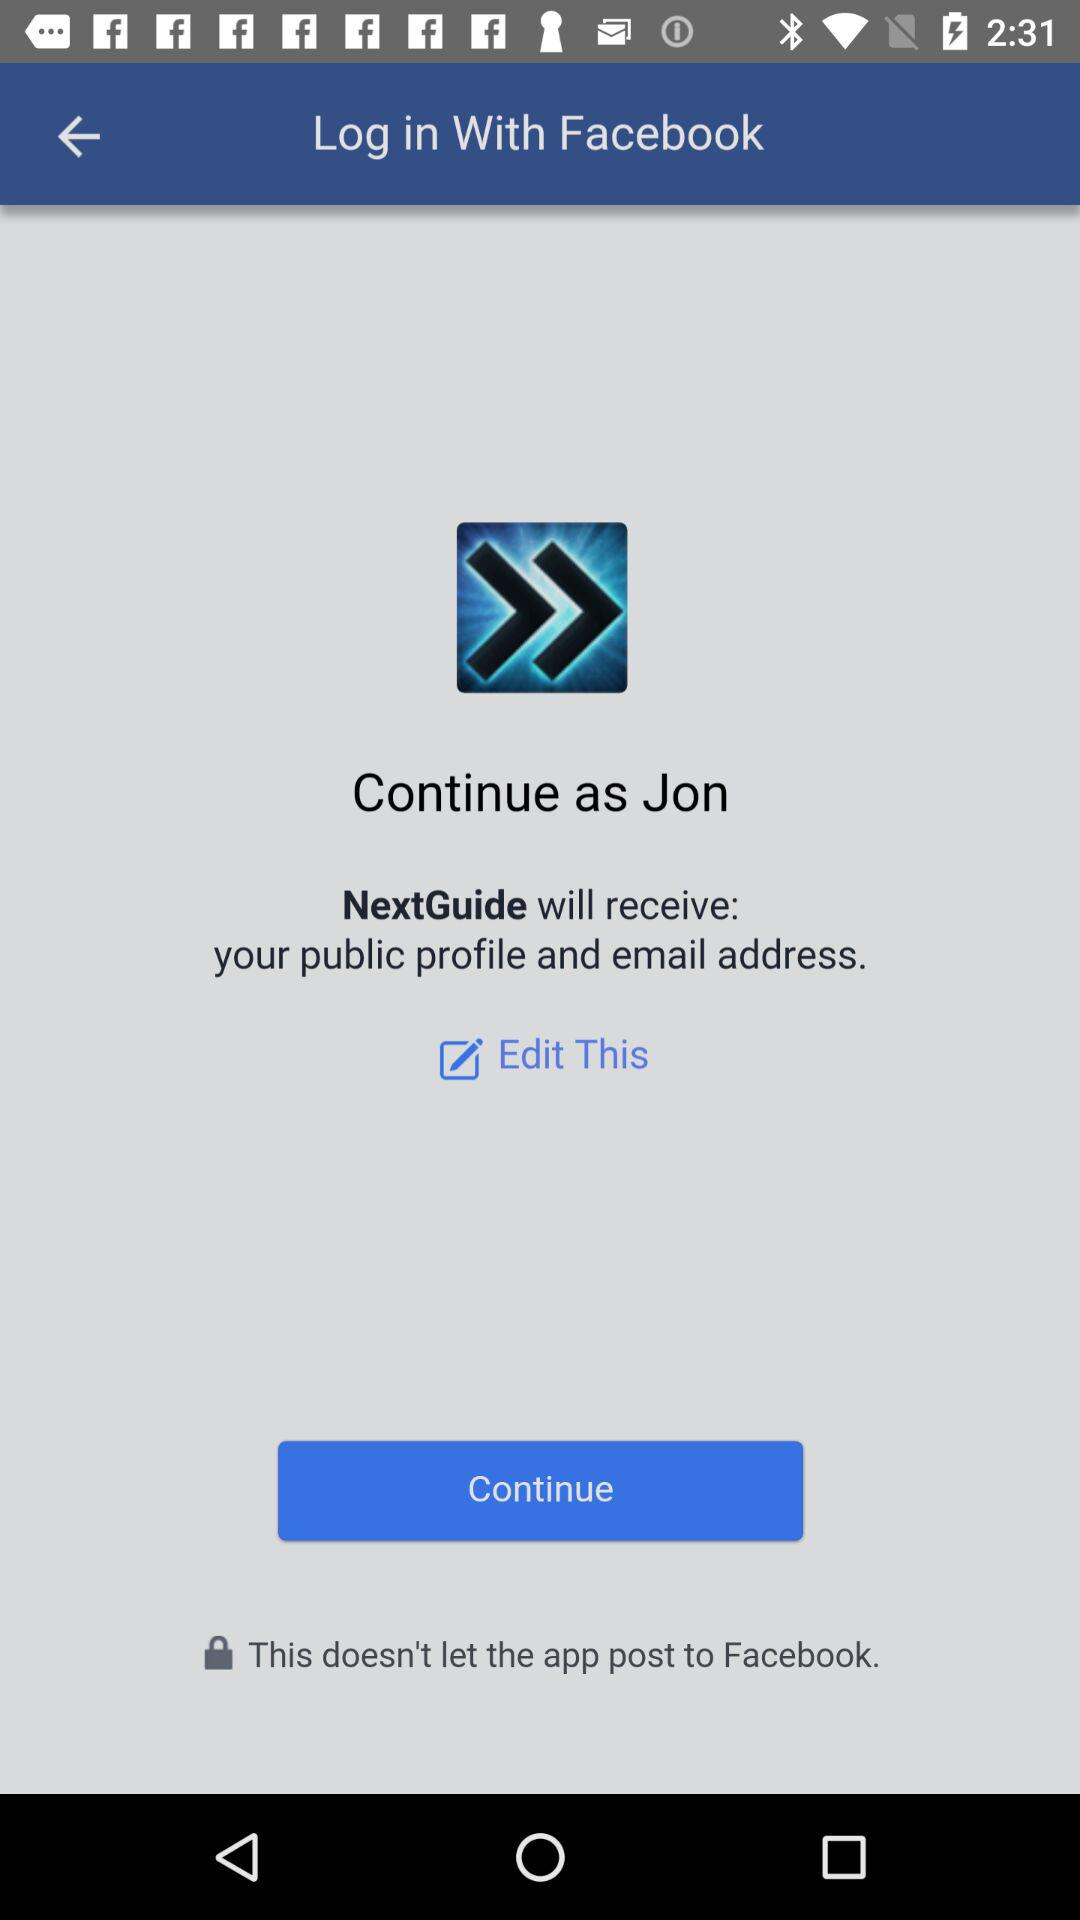What is the login name? The login name is Jon. 